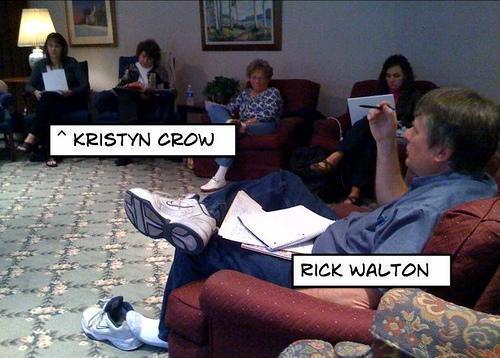How many people are in the photo?
Give a very brief answer. 5. How many couches are in the picture?
Give a very brief answer. 3. How many chairs are there?
Give a very brief answer. 3. 